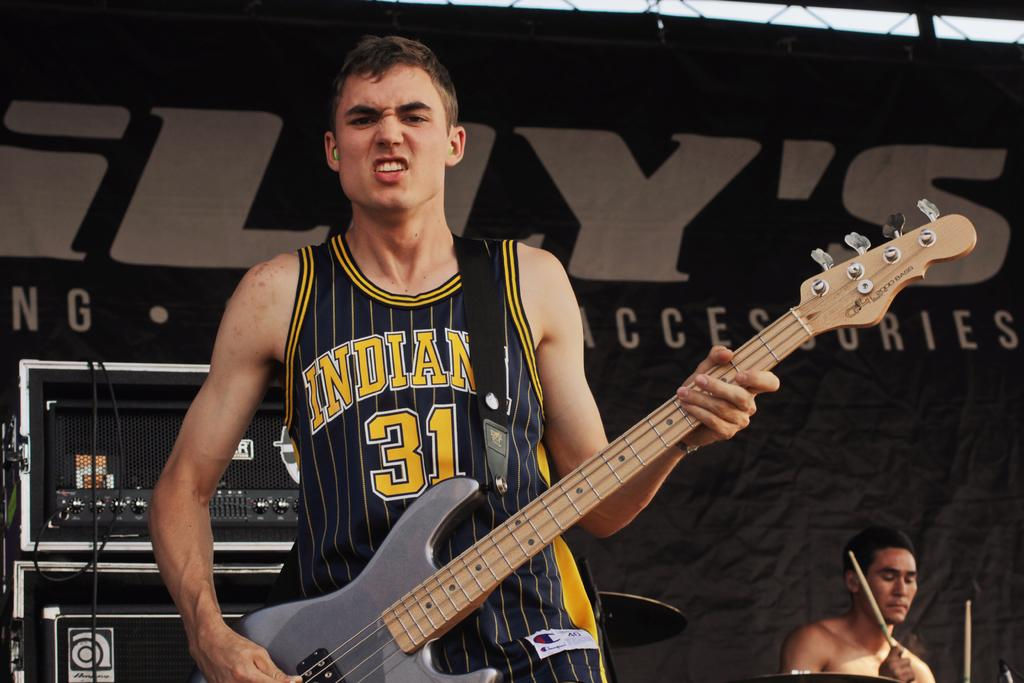<image>
Write a terse but informative summary of the picture. A man holding a guitar in a jersey that is black and in yellow letters says Indiana 31. 